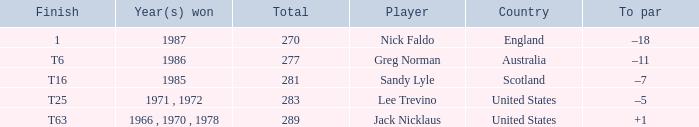How many totals have t6 as the finish? 277.0. Could you parse the entire table as a dict? {'header': ['Finish', 'Year(s) won', 'Total', 'Player', 'Country', 'To par'], 'rows': [['1', '1987', '270', 'Nick Faldo', 'England', '–18'], ['T6', '1986', '277', 'Greg Norman', 'Australia', '–11'], ['T16', '1985', '281', 'Sandy Lyle', 'Scotland', '–7'], ['T25', '1971 , 1972', '283', 'Lee Trevino', 'United States', '–5'], ['T63', '1966 , 1970 , 1978', '289', 'Jack Nicklaus', 'United States', '+1']]} 